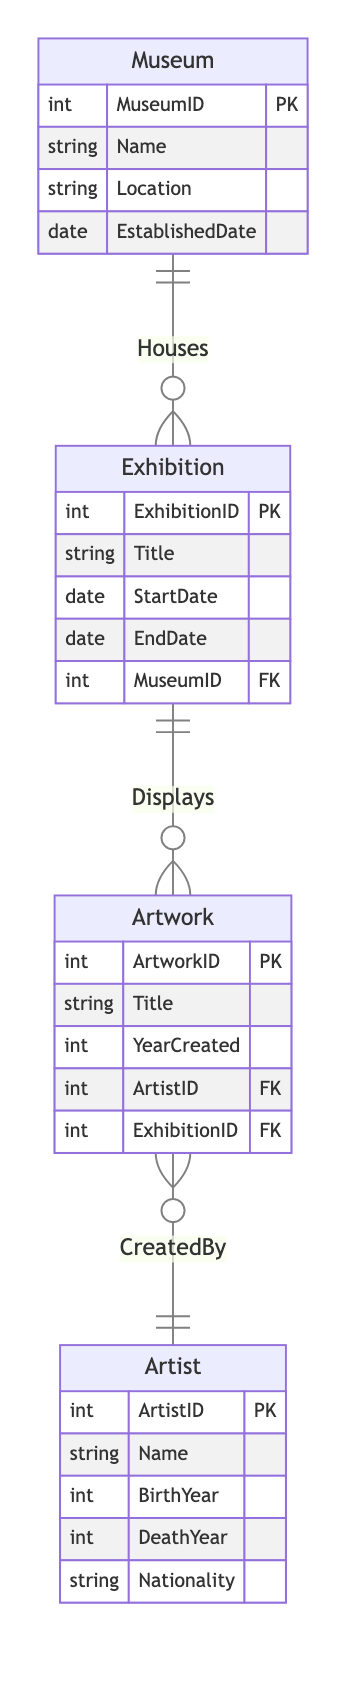What entities are in the diagram? The diagram includes four entities: Museum, Exhibition, Artwork, and Artist. These entities are depicted as boxes in the diagram, each containing a set of attributes.
Answer: Museum, Exhibition, Artwork, Artist What is the cardinality between Museum and Exhibition? The relationship between Museum and Exhibition is one to many (1:N). This means that one museum can host multiple exhibitions, as indicated by the notation in the diagram.
Answer: 1:N How many attributes does the Artwork entity have? The Artwork entity has four attributes: ArtworkID, Title, YearCreated, ArtistID, and ExhibitionID. The number of attributes is determined by counting those listed within the Artwork box.
Answer: 5 Which relationship connects Exhibition to Artwork? The relationship that connects Exhibition to Artwork is called "Displays". This relationship is visually represented by a line connecting the two entities with the label "Displays".
Answer: Displays How many entities are involved in the relationship "CreatedBy"? The "CreatedBy" relationship involves two entities: Artwork and Artist. This indicates that each artwork is associated with one artist, and the relationship connects these two entities.
Answer: 2 What is the primary key in the Museum entity? The primary key in the Museum entity is MuseumID. This is indicated in the entity definition where "PK" denotes the primary key, which uniquely identifies each museum record.
Answer: MuseumID What is the minimum number of artworks that must be displayed in an exhibition? The diagram indicates that an Exhibition can display zero or more Artworks due to its one-to-many relationship with Artwork. Therefore, the minimum is zero.
Answer: 0 What nationality information can be found in the Artist entity? The Artist entity contains an attribute for Nationality, which provides information about the country of origin of the artist.
Answer: Nationality In how many exhibitions can a single artwork be displayed? A single artwork can be displayed in only one exhibition, as indicated by the foreign key ExhibitionID in the Artwork entity which relates back to one Exhibition.
Answer: 1 